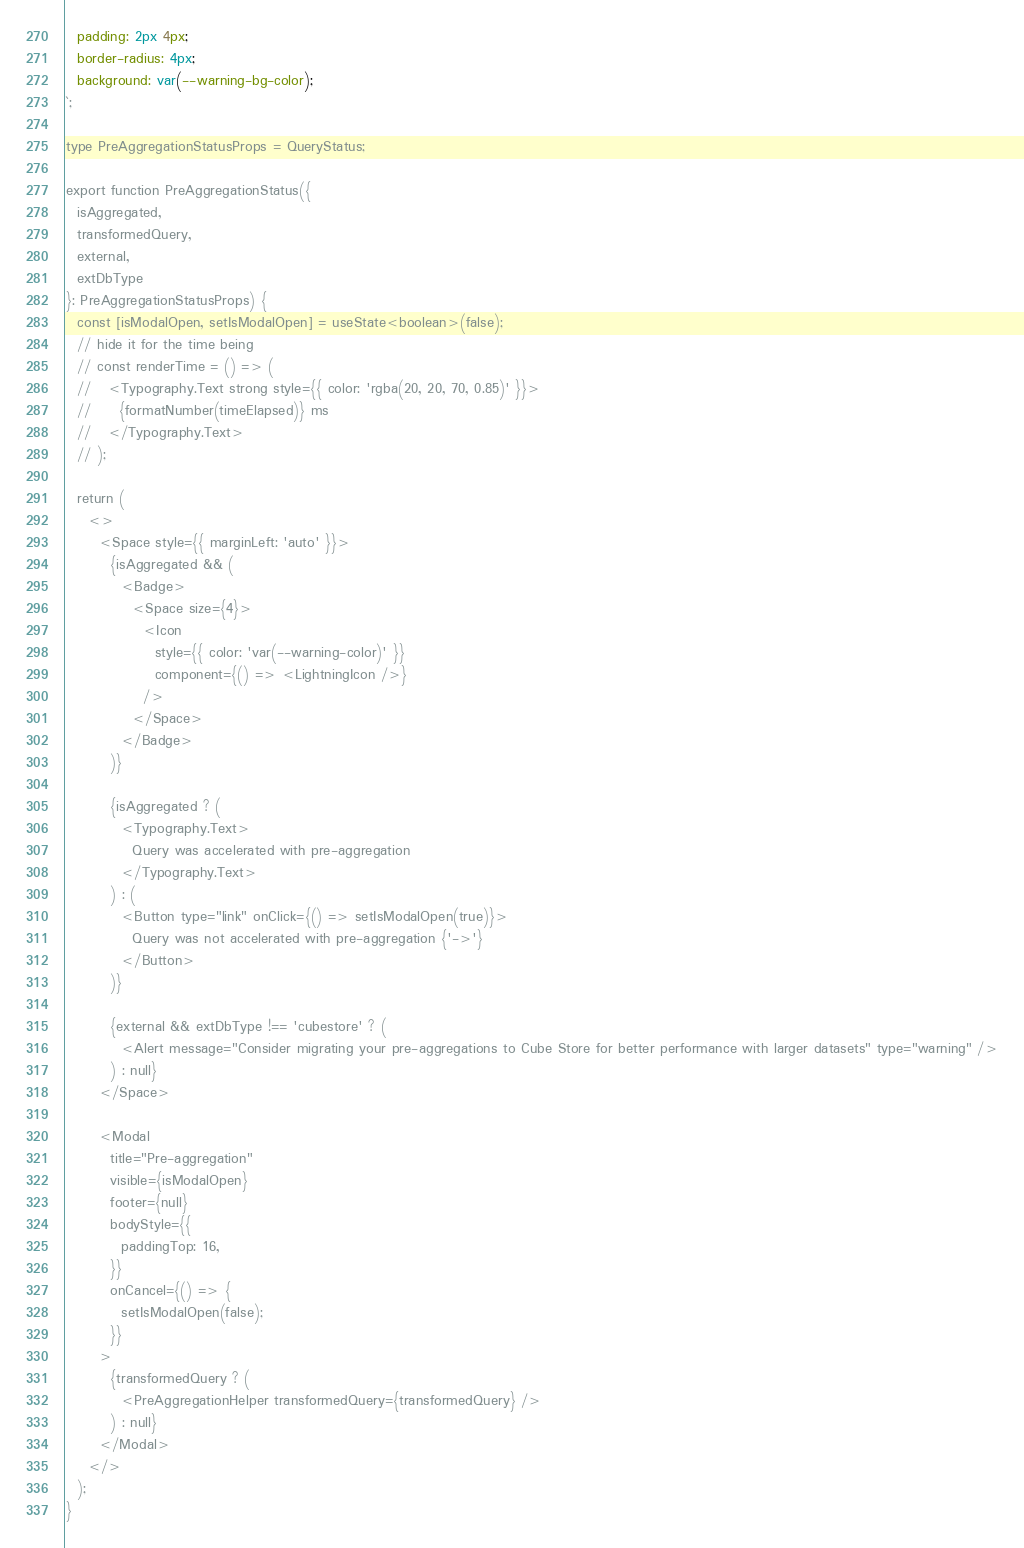Convert code to text. <code><loc_0><loc_0><loc_500><loc_500><_TypeScript_>  padding: 2px 4px;
  border-radius: 4px;
  background: var(--warning-bg-color);
`;

type PreAggregationStatusProps = QueryStatus;

export function PreAggregationStatus({
  isAggregated,
  transformedQuery,
  external,
  extDbType
}: PreAggregationStatusProps) {
  const [isModalOpen, setIsModalOpen] = useState<boolean>(false);
  // hide it for the time being
  // const renderTime = () => (
  //   <Typography.Text strong style={{ color: 'rgba(20, 20, 70, 0.85)' }}>
  //     {formatNumber(timeElapsed)} ms
  //   </Typography.Text>
  // );

  return (
    <>
      <Space style={{ marginLeft: 'auto' }}>
        {isAggregated && (
          <Badge>
            <Space size={4}>
              <Icon
                style={{ color: 'var(--warning-color)' }}
                component={() => <LightningIcon />}
              />
            </Space>
          </Badge>
        )}

        {isAggregated ? (
          <Typography.Text>
            Query was accelerated with pre-aggregation
          </Typography.Text>
        ) : (
          <Button type="link" onClick={() => setIsModalOpen(true)}>
            Query was not accelerated with pre-aggregation {'->'}
          </Button>
        )}

        {external && extDbType !== 'cubestore' ? (
          <Alert message="Consider migrating your pre-aggregations to Cube Store for better performance with larger datasets" type="warning" />
        ) : null}
      </Space>

      <Modal
        title="Pre-aggregation"
        visible={isModalOpen}
        footer={null}
        bodyStyle={{
          paddingTop: 16,
        }}
        onCancel={() => {
          setIsModalOpen(false);
        }}
      >
        {transformedQuery ? (
          <PreAggregationHelper transformedQuery={transformedQuery} />
        ) : null}
      </Modal>
    </>
  );
}
</code> 